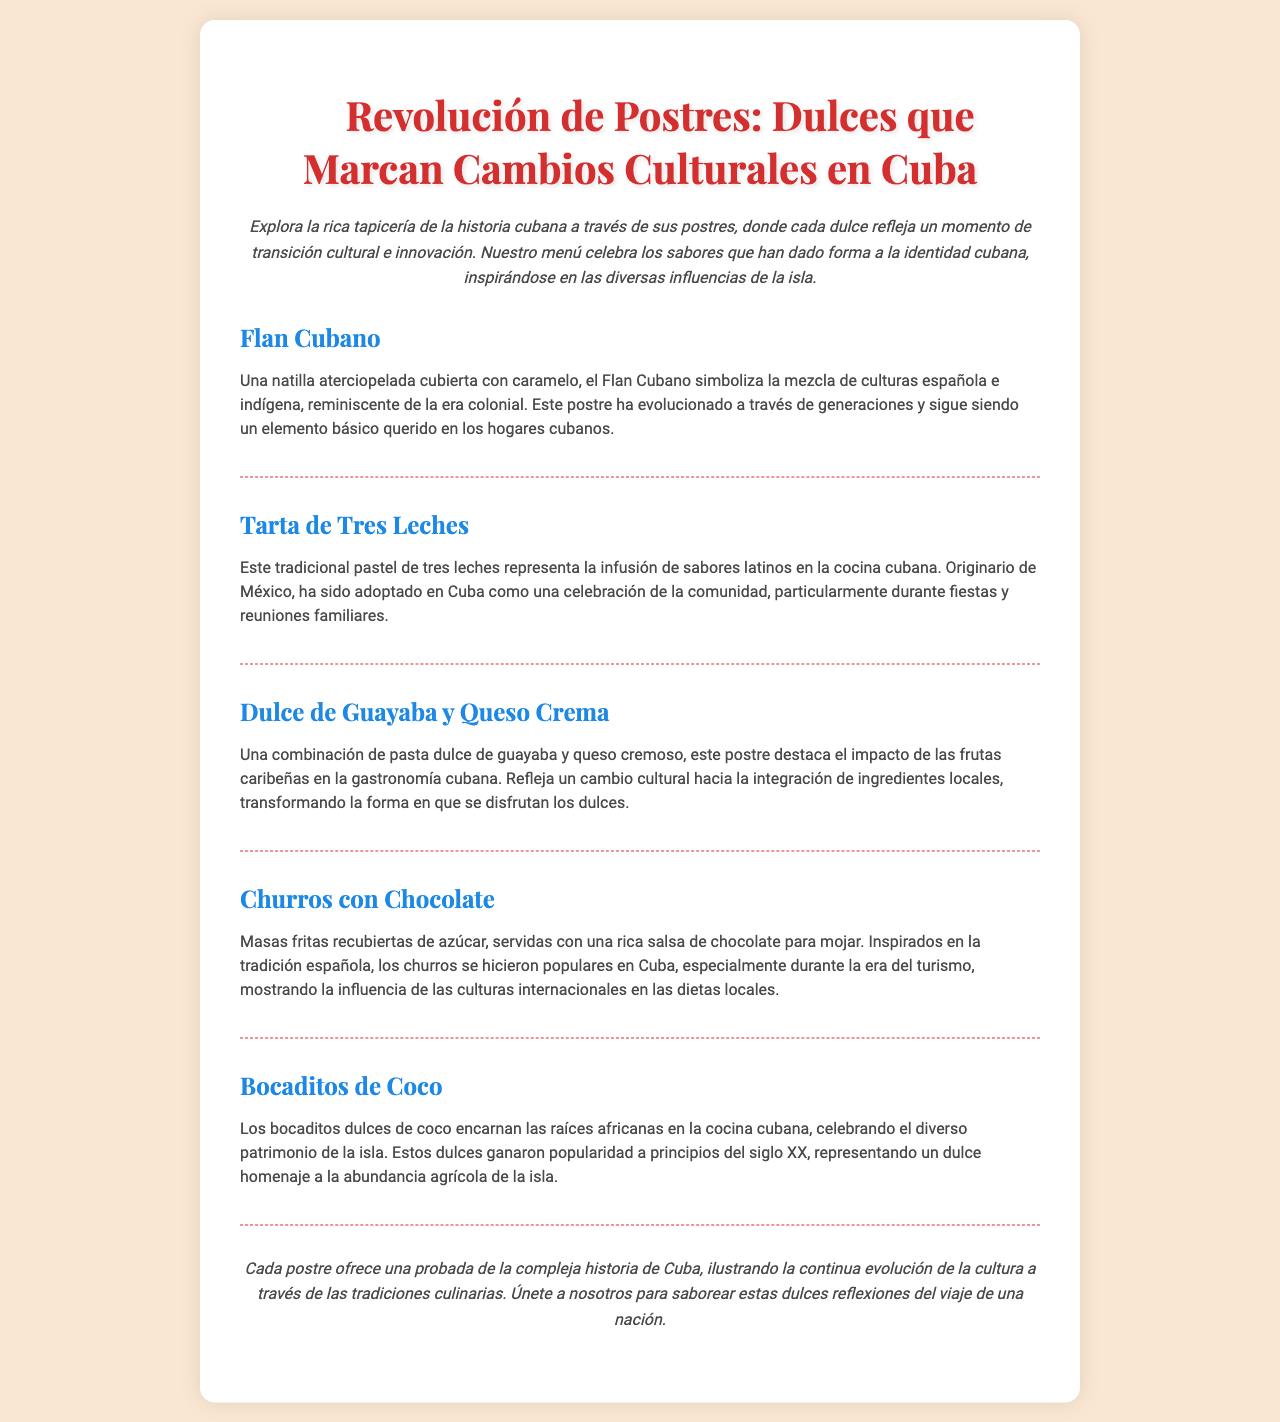¿Cuál es el primer postre mencionado? El primer postre mencionado en el menú es el Flan Cubano.
Answer: Flan Cubano ¿Qué representa la Tarta de Tres Leches? La Tarta de Tres Leches representa la infusión de sabores latinos en la cocina cubana.
Answer: Infusión de sabores latinos ¿Qué ingrediente principal destaca en el Dulce de Guayaba y Queso Crema? El ingrediente principal que destaca es la combinación de pasta dulce de guayaba y queso cremoso.
Answer: Pasta dulce de guayaba y queso cremoso ¿Qué influencias culturales se mencionan en relación a los Churros con Chocolate? Los Churros con Chocolate están inspirados en la tradición española y muestran la influencia de culturas internacionales.
Answer: Tradición española ¿En qué siglo ganaron popularidad los Bocaditos de Coco? Los Bocaditos de Coco ganaron popularidad a principios del siglo XX.
Answer: Principios del siglo XX ¿Qué refleja cada postre según la conclusión del menú? Cada postre refleja la compleja historia de Cuba y la evolución de la cultura a través de las tradiciones culinarias.
Answer: Compleja historia de Cuba ¿Cuántos postres se mencionan en total en el menú? Se mencionan cinco postres en total.
Answer: Cinco postres ¿Qué estilo de postre se asocia con el impacto de las frutas caribeñas? El Dulce de Guayaba y Queso Crema se asocia con el impacto de las frutas caribeñas.
Answer: Dulce de Guayaba y Queso Crema 